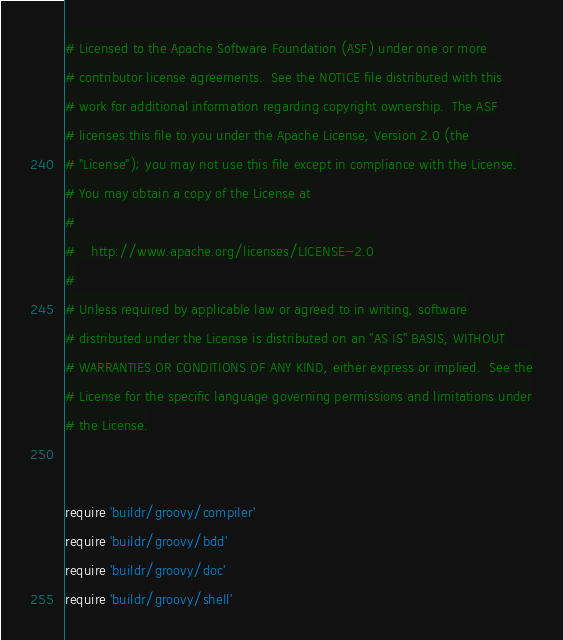Convert code to text. <code><loc_0><loc_0><loc_500><loc_500><_Ruby_># Licensed to the Apache Software Foundation (ASF) under one or more
# contributor license agreements.  See the NOTICE file distributed with this
# work for additional information regarding copyright ownership.  The ASF
# licenses this file to you under the Apache License, Version 2.0 (the
# "License"); you may not use this file except in compliance with the License.
# You may obtain a copy of the License at
#
#    http://www.apache.org/licenses/LICENSE-2.0
#
# Unless required by applicable law or agreed to in writing, software
# distributed under the License is distributed on an "AS IS" BASIS, WITHOUT
# WARRANTIES OR CONDITIONS OF ANY KIND, either express or implied.  See the
# License for the specific language governing permissions and limitations under
# the License.


require 'buildr/groovy/compiler'
require 'buildr/groovy/bdd'
require 'buildr/groovy/doc'
require 'buildr/groovy/shell'
</code> 